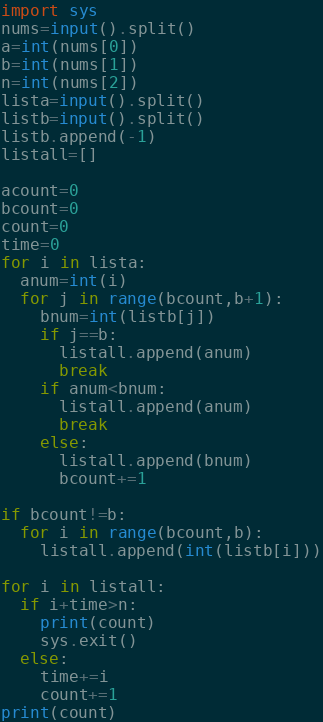Convert code to text. <code><loc_0><loc_0><loc_500><loc_500><_Python_>import sys
nums=input().split()
a=int(nums[0])
b=int(nums[1])
n=int(nums[2])
lista=input().split()
listb=input().split()
listb.append(-1)
listall=[]

acount=0
bcount=0
count=0
time=0
for i in lista:
  anum=int(i)
  for j in range(bcount,b+1):
    bnum=int(listb[j])
    if j==b:
      listall.append(anum)
      break
    if anum<bnum:
      listall.append(anum)
      break
    else:
      listall.append(bnum)
      bcount+=1

if bcount!=b:
  for i in range(bcount,b):
    listall.append(int(listb[i]))

for i in listall:
  if i+time>n:
    print(count)
    sys.exit()
  else:
    time+=i
    count+=1
print(count)
</code> 